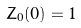<formula> <loc_0><loc_0><loc_500><loc_500>Z _ { 0 } ( 0 ) = 1</formula> 